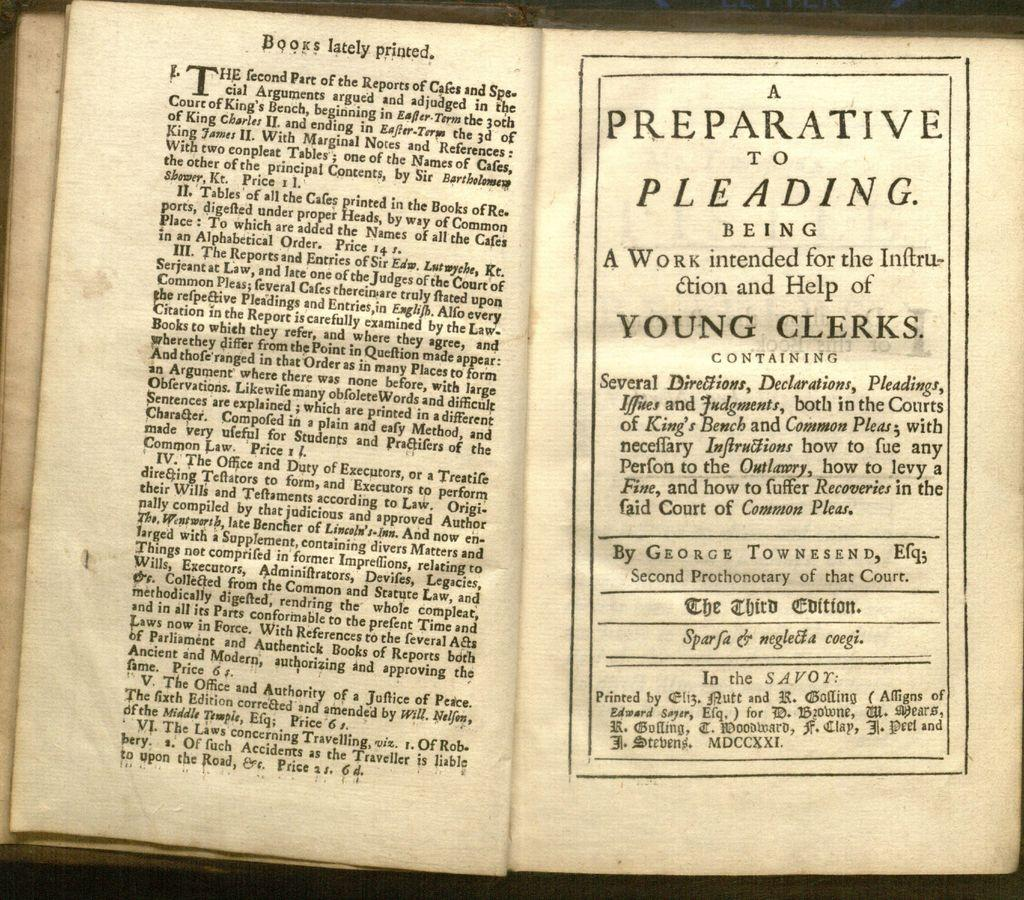<image>
Write a terse but informative summary of the picture. An image of a book, "A Preparataive to Pleading" 